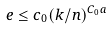<formula> <loc_0><loc_0><loc_500><loc_500>\ e \leq c _ { 0 } ( k / n ) ^ { C _ { 0 } a }</formula> 